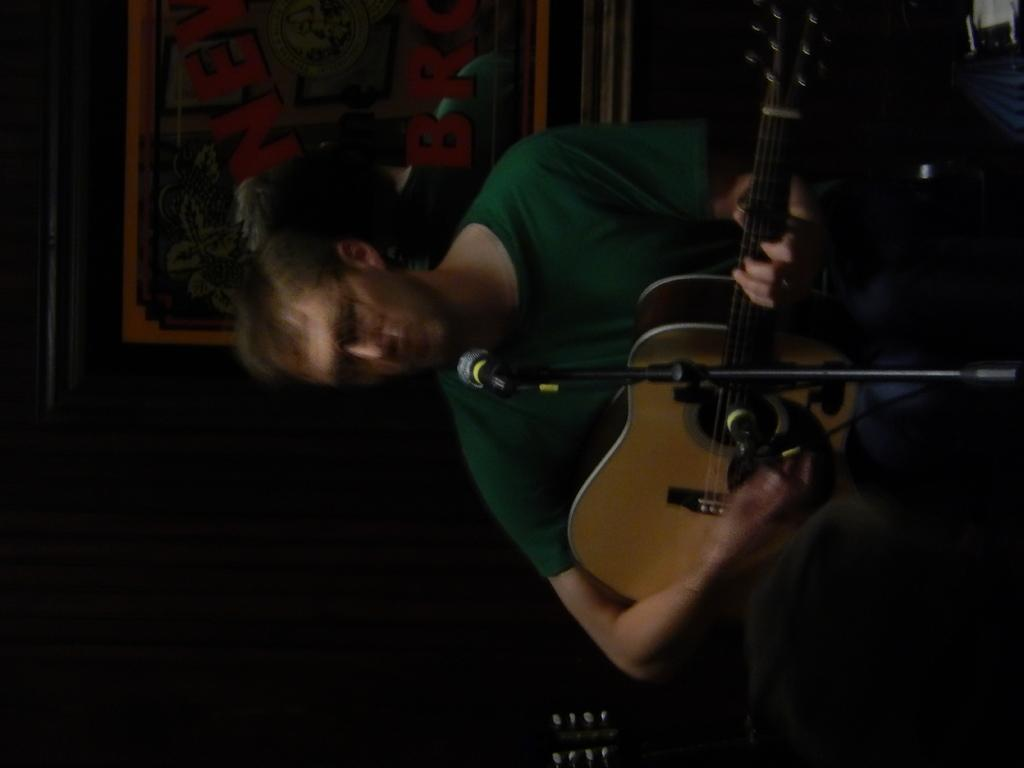What is the main subject of the image? There is a guy in the image. What is the guy doing in the image? The guy is playing the guitar. What object is in front of the guy? There is a microphone in front of the guy. What is the aftermath of the drum in the image? There is no drum present in the image, so there is no aftermath to discuss. 